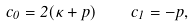Convert formula to latex. <formula><loc_0><loc_0><loc_500><loc_500>c _ { 0 } = 2 ( \kappa + p ) \quad c _ { 1 } = - p ,</formula> 